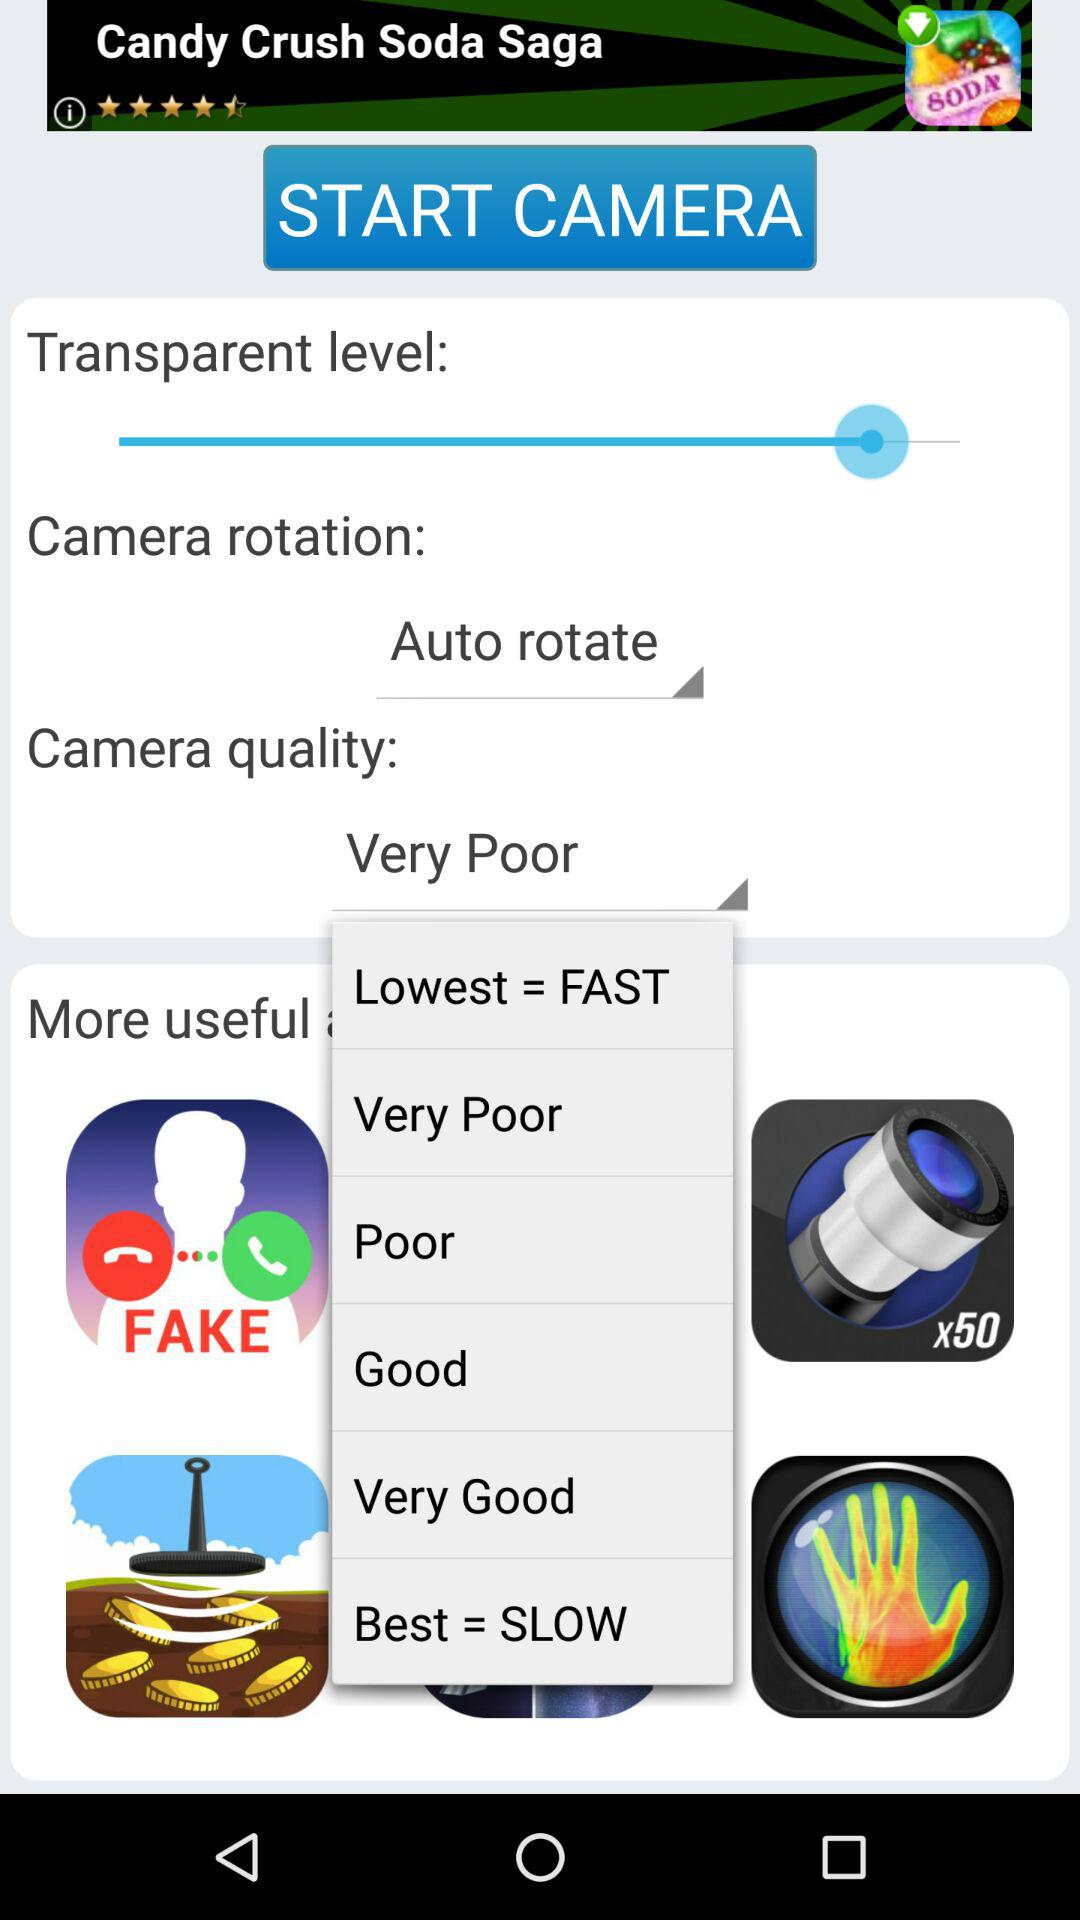What is camera rotation? Camera rotation is auto rotate. 